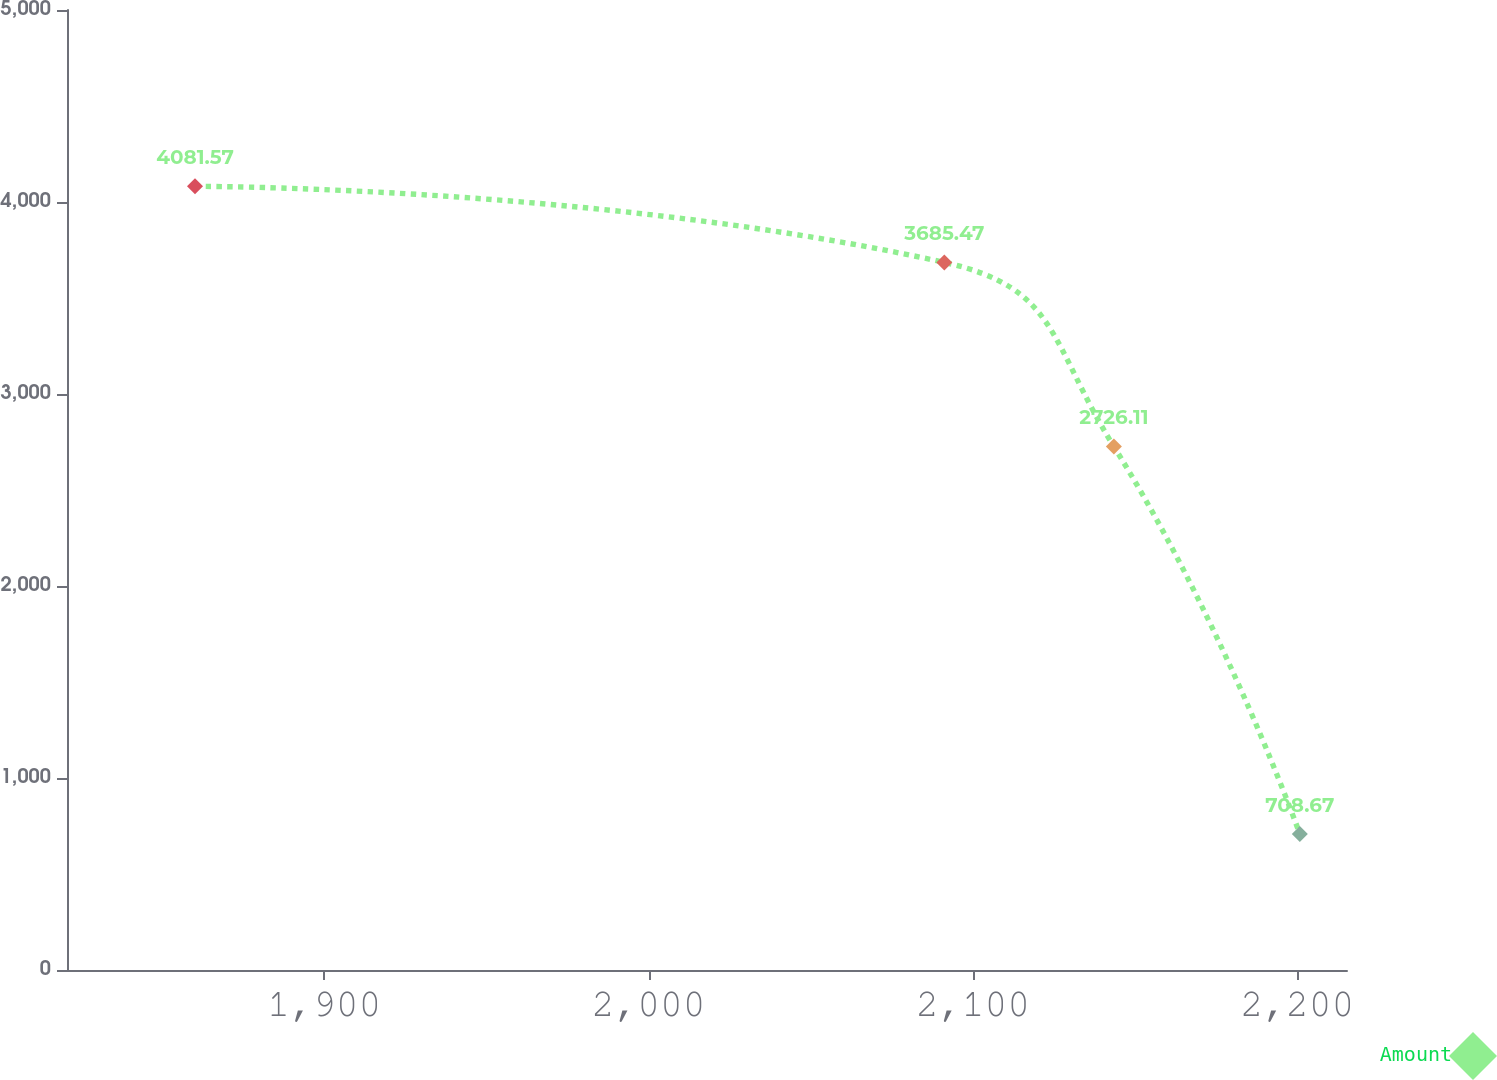<chart> <loc_0><loc_0><loc_500><loc_500><line_chart><ecel><fcel>Amount<nl><fcel>1860.13<fcel>4081.57<nl><fcel>2091.14<fcel>3685.47<nl><fcel>2143.43<fcel>2726.11<nl><fcel>2200.74<fcel>708.67<nl><fcel>2254.76<fcel>7.42<nl></chart> 